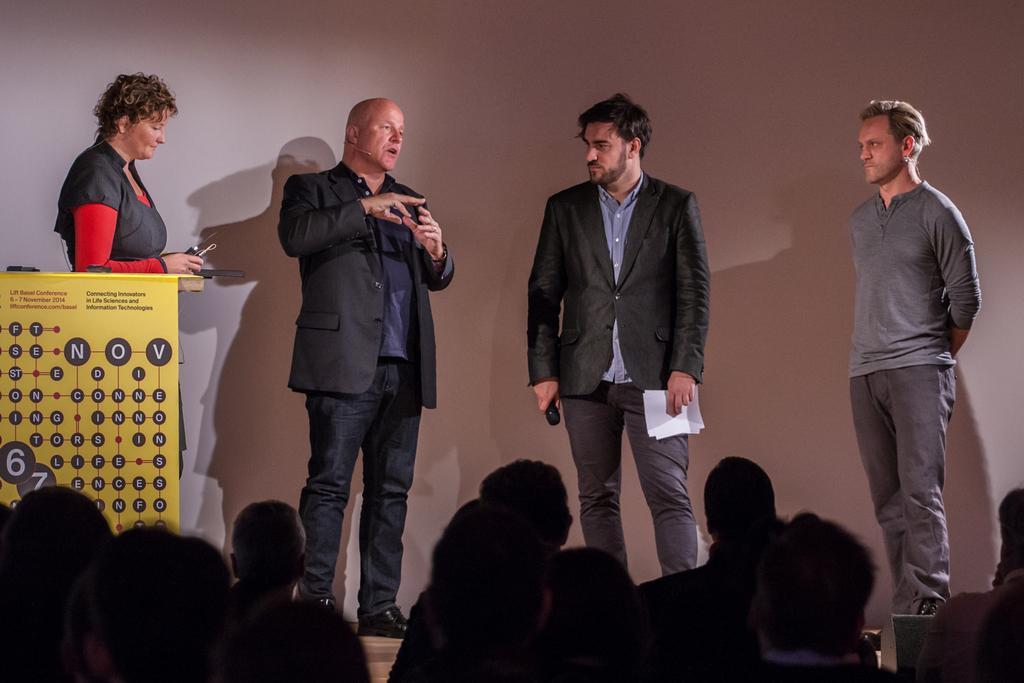How would you summarize this image in a sentence or two? There are four people standing. This looks like a banner with the letters on it. At the bottom of the image, I can see a group of people. In the background, that looks like a wall, which is white in color. 